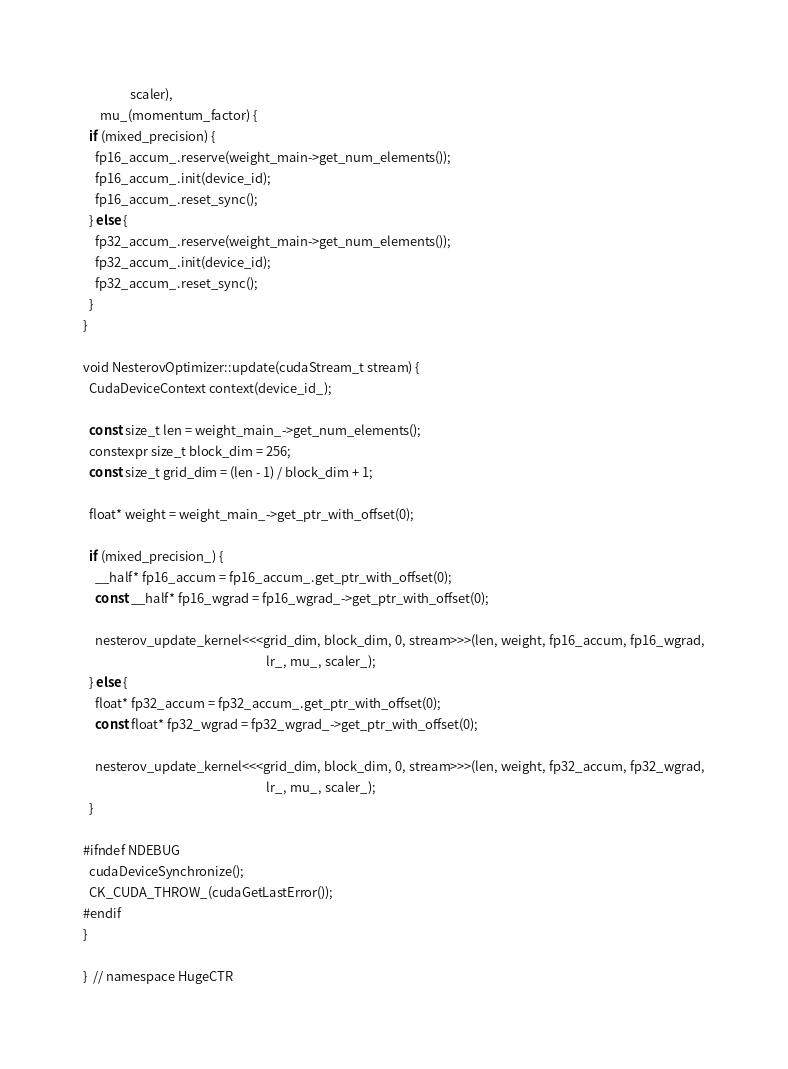Convert code to text. <code><loc_0><loc_0><loc_500><loc_500><_Cuda_>                scaler),
      mu_(momentum_factor) {
  if (mixed_precision) {
    fp16_accum_.reserve(weight_main->get_num_elements());
    fp16_accum_.init(device_id);
    fp16_accum_.reset_sync();
  } else {
    fp32_accum_.reserve(weight_main->get_num_elements());
    fp32_accum_.init(device_id);
    fp32_accum_.reset_sync();
  }
}

void NesterovOptimizer::update(cudaStream_t stream) {
  CudaDeviceContext context(device_id_);

  const size_t len = weight_main_->get_num_elements();
  constexpr size_t block_dim = 256;
  const size_t grid_dim = (len - 1) / block_dim + 1;

  float* weight = weight_main_->get_ptr_with_offset(0);

  if (mixed_precision_) {
    __half* fp16_accum = fp16_accum_.get_ptr_with_offset(0);
    const __half* fp16_wgrad = fp16_wgrad_->get_ptr_with_offset(0);

    nesterov_update_kernel<<<grid_dim, block_dim, 0, stream>>>(len, weight, fp16_accum, fp16_wgrad,
                                                               lr_, mu_, scaler_);
  } else {
    float* fp32_accum = fp32_accum_.get_ptr_with_offset(0);
    const float* fp32_wgrad = fp32_wgrad_->get_ptr_with_offset(0);

    nesterov_update_kernel<<<grid_dim, block_dim, 0, stream>>>(len, weight, fp32_accum, fp32_wgrad,
                                                               lr_, mu_, scaler_);
  }

#ifndef NDEBUG
  cudaDeviceSynchronize();
  CK_CUDA_THROW_(cudaGetLastError());
#endif
}

}  // namespace HugeCTR
</code> 